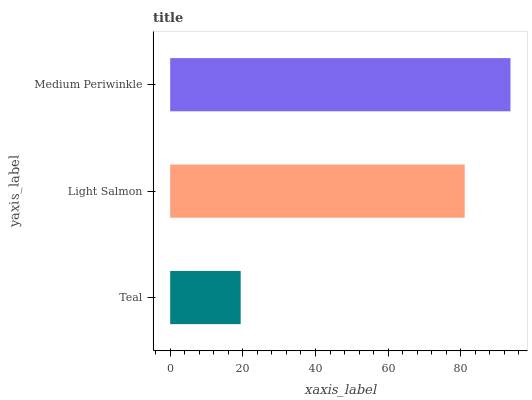Is Teal the minimum?
Answer yes or no. Yes. Is Medium Periwinkle the maximum?
Answer yes or no. Yes. Is Light Salmon the minimum?
Answer yes or no. No. Is Light Salmon the maximum?
Answer yes or no. No. Is Light Salmon greater than Teal?
Answer yes or no. Yes. Is Teal less than Light Salmon?
Answer yes or no. Yes. Is Teal greater than Light Salmon?
Answer yes or no. No. Is Light Salmon less than Teal?
Answer yes or no. No. Is Light Salmon the high median?
Answer yes or no. Yes. Is Light Salmon the low median?
Answer yes or no. Yes. Is Medium Periwinkle the high median?
Answer yes or no. No. Is Teal the low median?
Answer yes or no. No. 